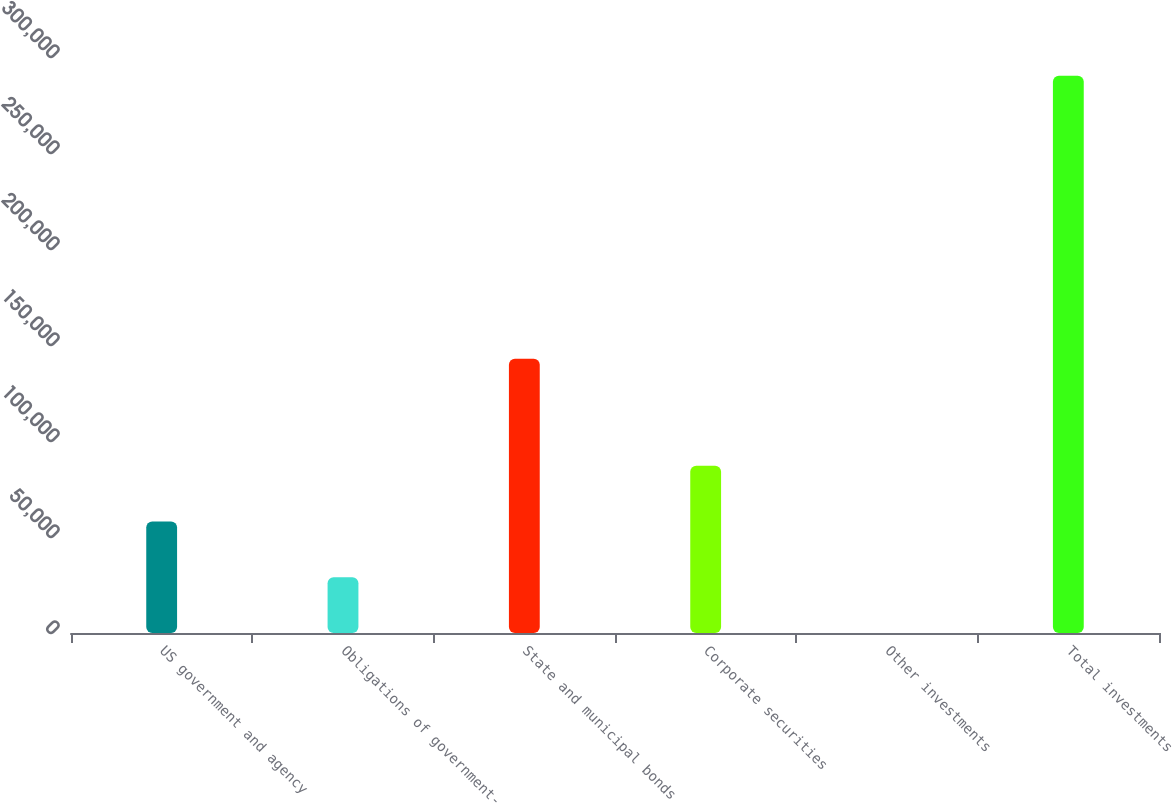Convert chart to OTSL. <chart><loc_0><loc_0><loc_500><loc_500><bar_chart><fcel>US government and agency<fcel>Obligations of government-<fcel>State and municipal bonds<fcel>Corporate securities<fcel>Other investments<fcel>Total investments<nl><fcel>58084.2<fcel>29060.1<fcel>142873<fcel>87108.3<fcel>36<fcel>290277<nl></chart> 